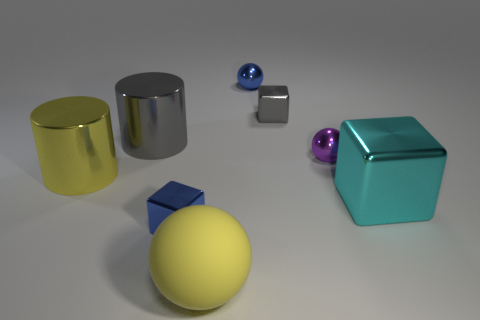Is there anything else that is made of the same material as the large ball?
Your response must be concise. No. Is there anything else that is the same color as the large block?
Your answer should be very brief. No. What number of other objects are there of the same size as the blue cube?
Make the answer very short. 3. What shape is the blue thing that is behind the small shiny block that is behind the tiny blue metal object on the left side of the big yellow sphere?
Keep it short and to the point. Sphere. How many things are tiny cubes that are behind the yellow cylinder or tiny blue things that are right of the big yellow rubber ball?
Make the answer very short. 2. There is a blue metallic object behind the small metal thing left of the yellow rubber sphere; what is its size?
Provide a succinct answer. Small. There is a small thing that is in front of the cyan block; does it have the same color as the matte object?
Offer a very short reply. No. Is there another big object that has the same shape as the big gray thing?
Give a very brief answer. Yes. What color is the other metal sphere that is the same size as the purple sphere?
Provide a succinct answer. Blue. There is a shiny ball that is to the left of the tiny purple object; what size is it?
Your answer should be very brief. Small. 